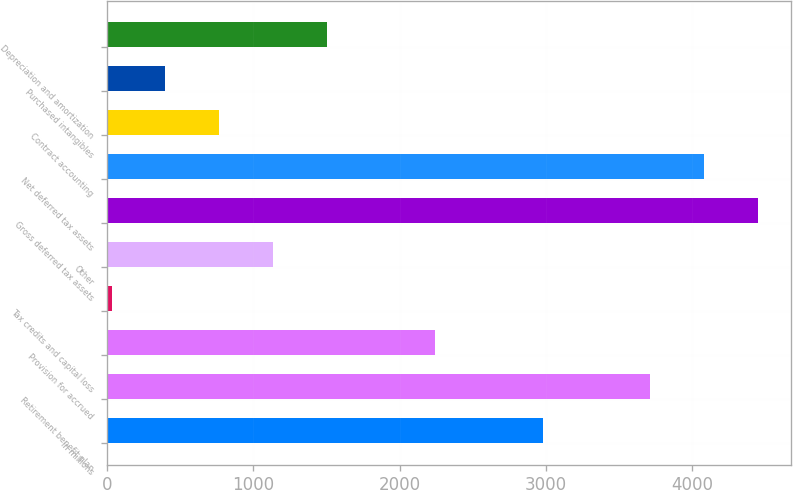Convert chart to OTSL. <chart><loc_0><loc_0><loc_500><loc_500><bar_chart><fcel>in millions<fcel>Retirement benefit plan<fcel>Provision for accrued<fcel>Tax credits and capital loss<fcel>Other<fcel>Gross deferred tax assets<fcel>Net deferred tax assets<fcel>Contract accounting<fcel>Purchased intangibles<fcel>Depreciation and amortization<nl><fcel>2977<fcel>3713<fcel>2241<fcel>33<fcel>1137<fcel>4449<fcel>4081<fcel>769<fcel>401<fcel>1505<nl></chart> 